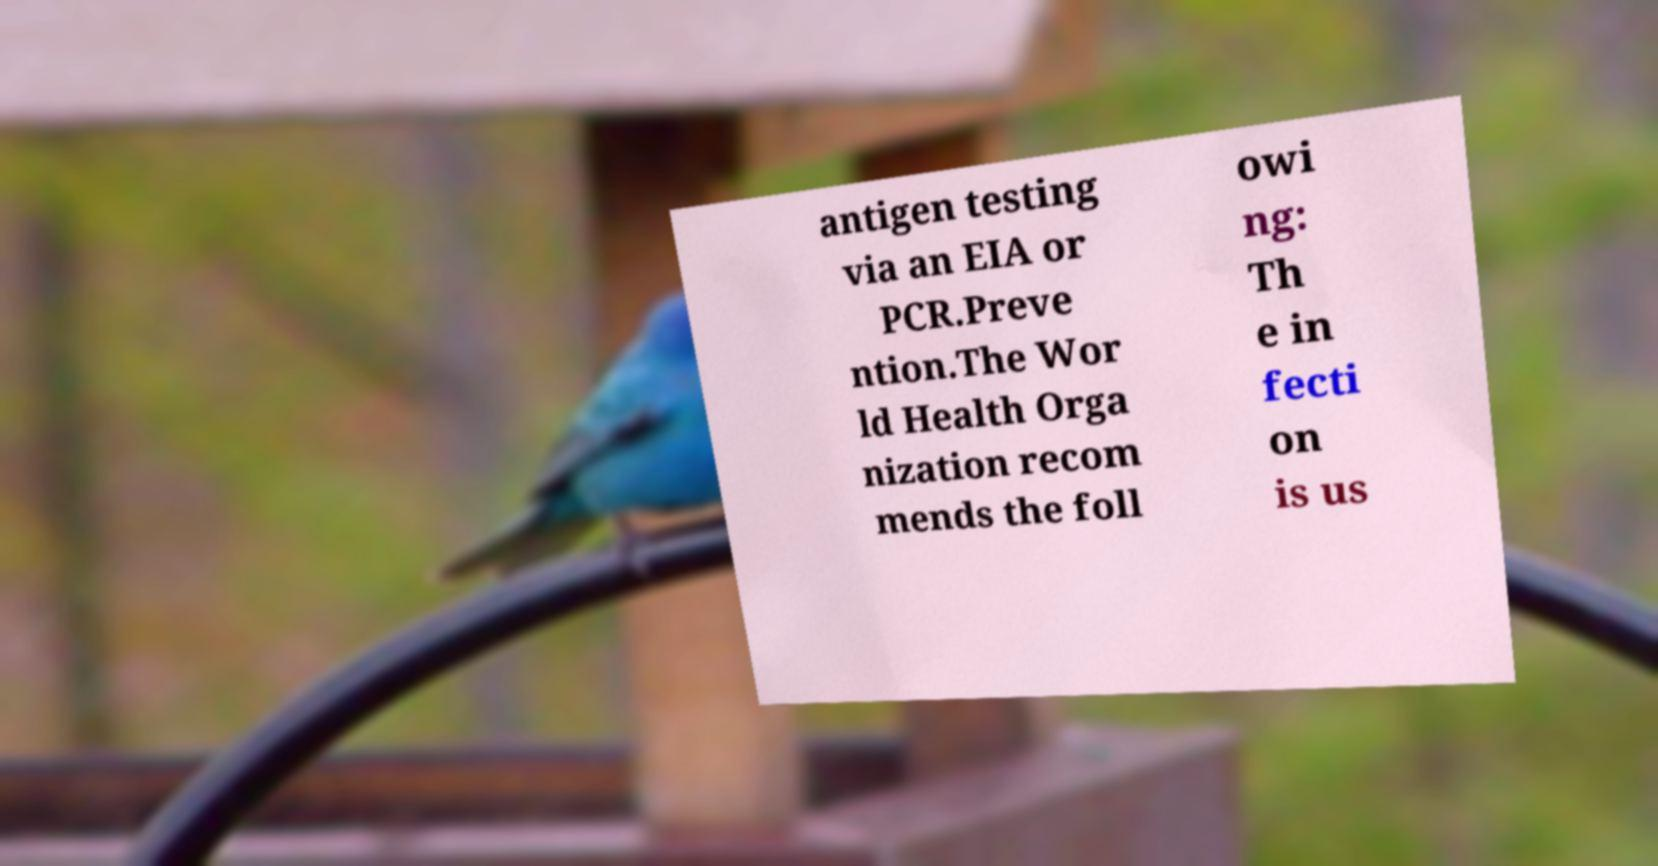There's text embedded in this image that I need extracted. Can you transcribe it verbatim? antigen testing via an EIA or PCR.Preve ntion.The Wor ld Health Orga nization recom mends the foll owi ng: Th e in fecti on is us 